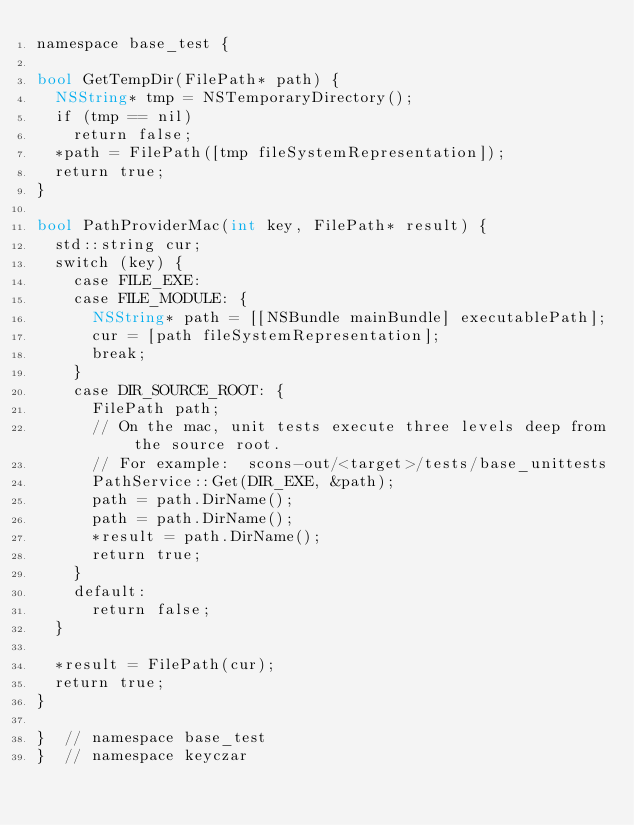<code> <loc_0><loc_0><loc_500><loc_500><_ObjectiveC_>namespace base_test {

bool GetTempDir(FilePath* path) {
  NSString* tmp = NSTemporaryDirectory();
  if (tmp == nil)
    return false;
  *path = FilePath([tmp fileSystemRepresentation]);
  return true;
}

bool PathProviderMac(int key, FilePath* result) {
  std::string cur;
  switch (key) {
    case FILE_EXE:
    case FILE_MODULE: {
      NSString* path = [[NSBundle mainBundle] executablePath];
      cur = [path fileSystemRepresentation];
      break;
    }
    case DIR_SOURCE_ROOT: {
      FilePath path;
      // On the mac, unit tests execute three levels deep from the source root.
      // For example:  scons-out/<target>/tests/base_unittests
      PathService::Get(DIR_EXE, &path);
      path = path.DirName();
      path = path.DirName();
      *result = path.DirName();
      return true;
    }
    default:
      return false;
  }

  *result = FilePath(cur);
  return true;
}

}  // namespace base_test
}  // namespace keyczar
</code> 